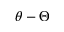<formula> <loc_0><loc_0><loc_500><loc_500>\theta - \Theta</formula> 